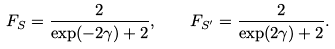<formula> <loc_0><loc_0><loc_500><loc_500>F _ { S } = \frac { 2 } { \exp ( - 2 \gamma ) + 2 } , \quad F _ { S ^ { \prime } } = \frac { 2 } { \exp ( 2 \gamma ) + 2 } .</formula> 